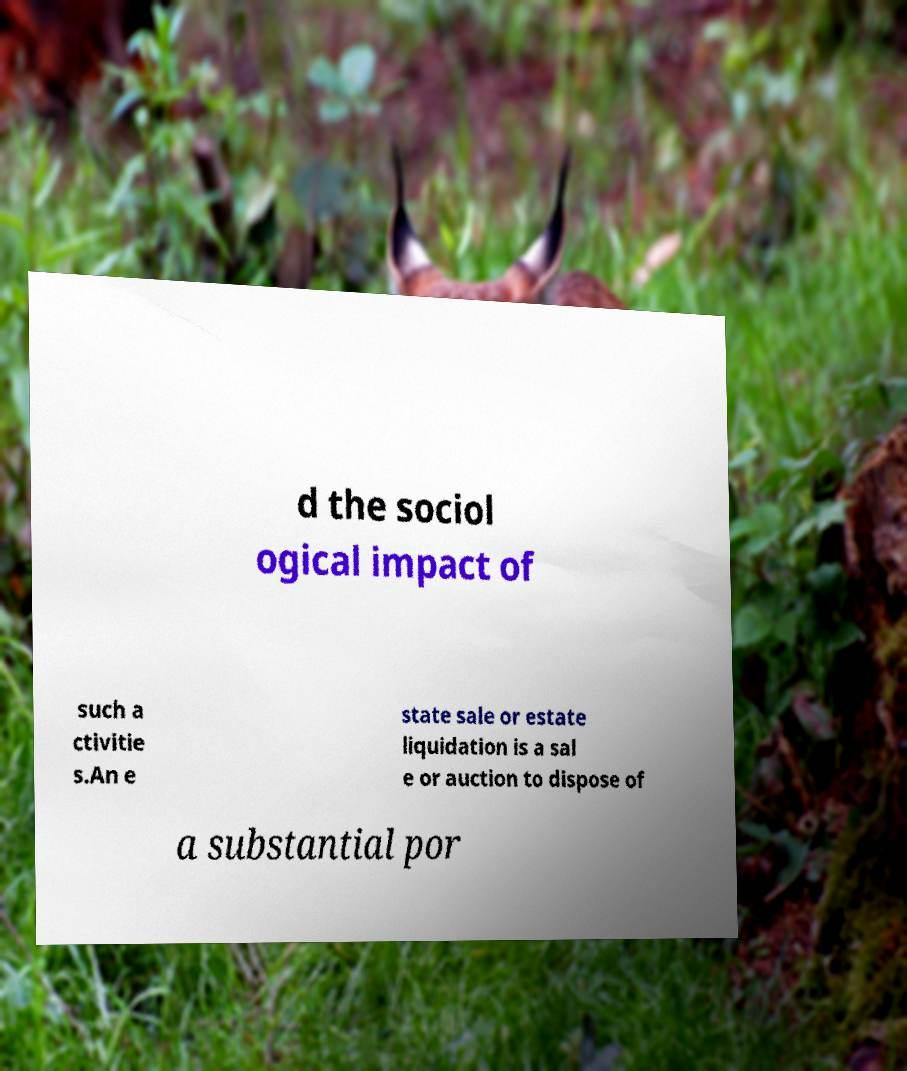Can you accurately transcribe the text from the provided image for me? d the sociol ogical impact of such a ctivitie s.An e state sale or estate liquidation is a sal e or auction to dispose of a substantial por 